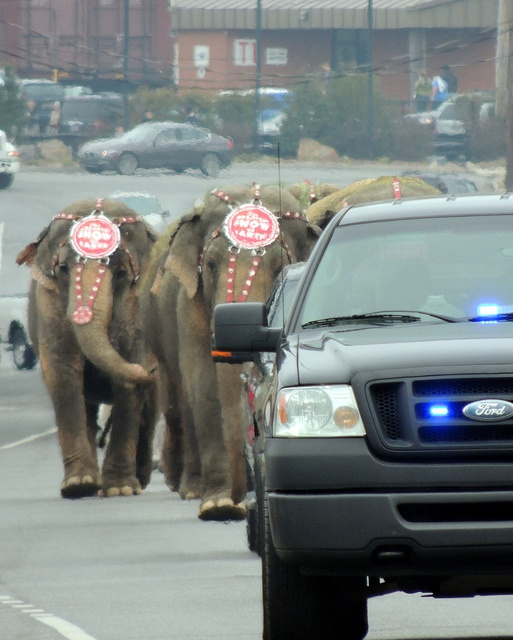Describe the objects in this image and their specific colors. I can see car in gray, black, darkgray, and lightgray tones, elephant in gray, black, and darkgray tones, elephant in gray and black tones, car in gray and darkgray tones, and elephant in gray, darkgray, and tan tones in this image. 